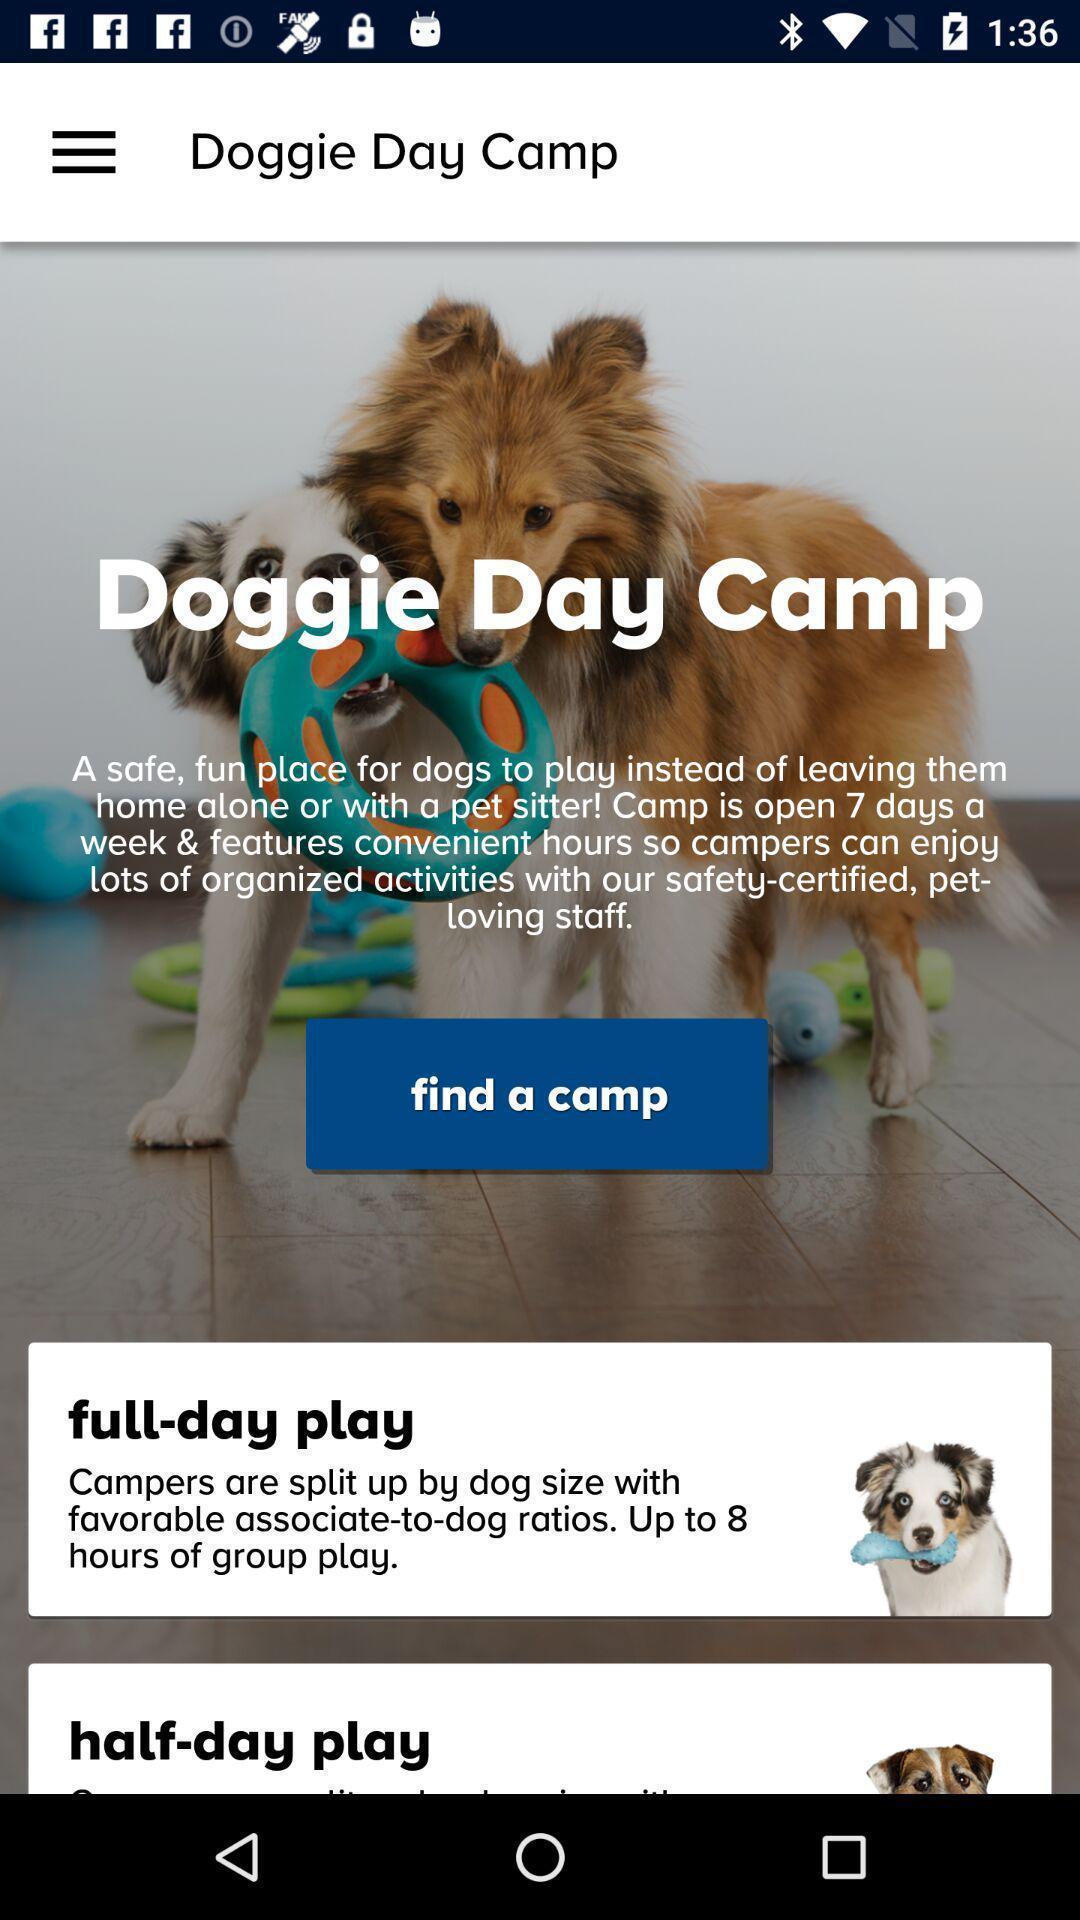Give me a summary of this screen capture. Screen shows information on pets app. 